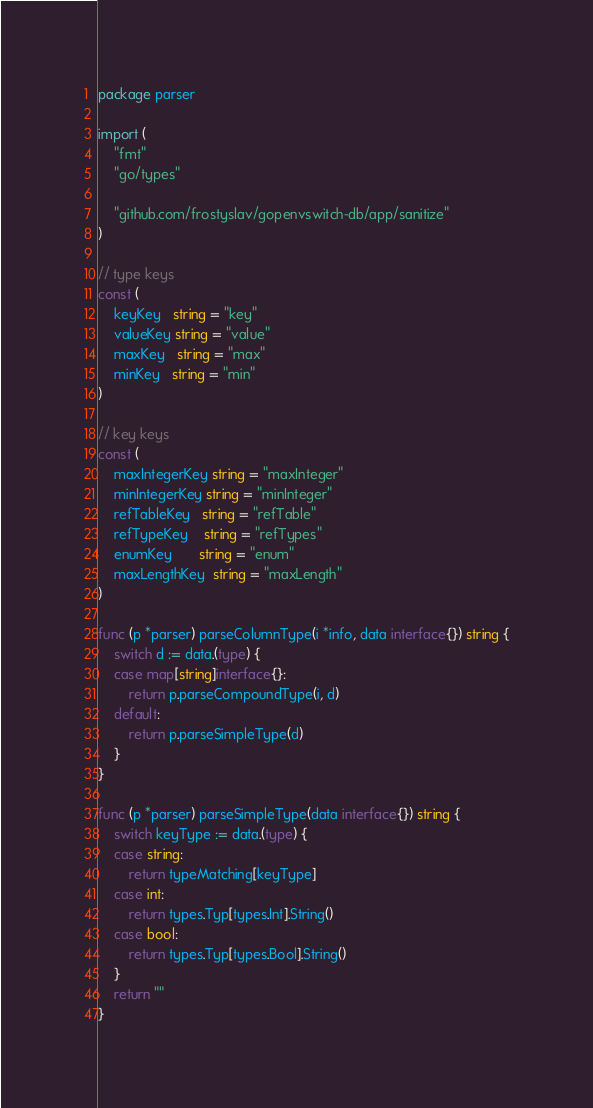<code> <loc_0><loc_0><loc_500><loc_500><_Go_>package parser

import (
	"fmt"
	"go/types"

	"github.com/frostyslav/gopenvswitch-db/app/sanitize"
)

// type keys
const (
	keyKey   string = "key"
	valueKey string = "value"
	maxKey   string = "max"
	minKey   string = "min"
)

// key keys
const (
	maxIntegerKey string = "maxInteger"
	minIntegerKey string = "minInteger"
	refTableKey   string = "refTable"
	refTypeKey    string = "refTypes"
	enumKey       string = "enum"
	maxLengthKey  string = "maxLength"
)

func (p *parser) parseColumnType(i *info, data interface{}) string {
	switch d := data.(type) {
	case map[string]interface{}:
		return p.parseCompoundType(i, d)
	default:
		return p.parseSimpleType(d)
	}
}

func (p *parser) parseSimpleType(data interface{}) string {
	switch keyType := data.(type) {
	case string:
		return typeMatching[keyType]
	case int:
		return types.Typ[types.Int].String()
	case bool:
		return types.Typ[types.Bool].String()
	}
	return ""
}
</code> 